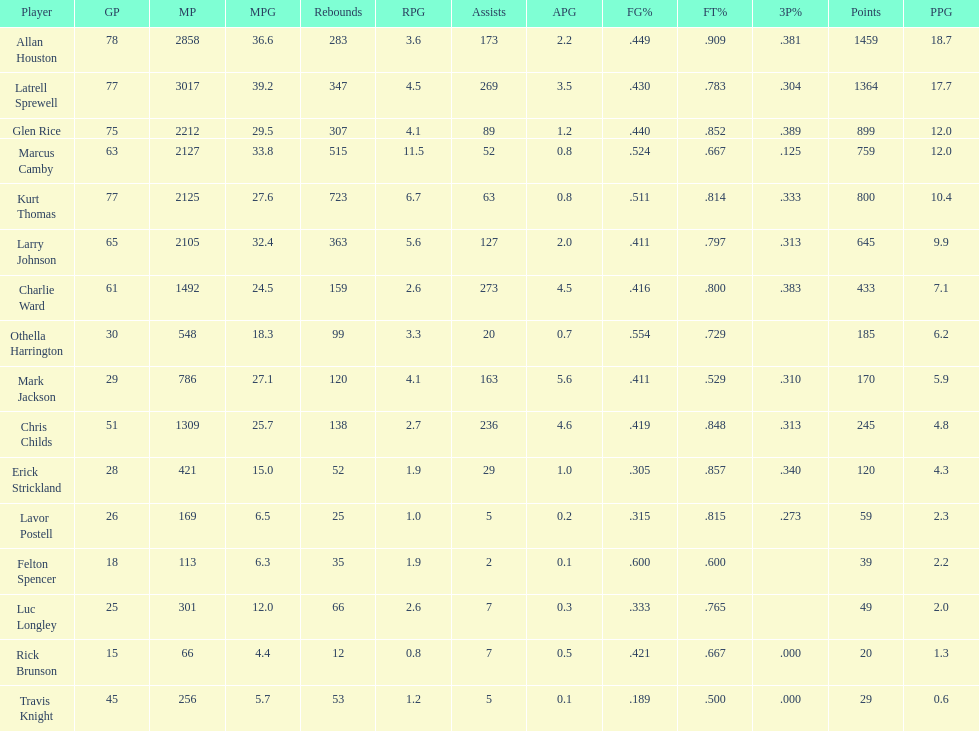Give the number of players covered by the table. 16. 